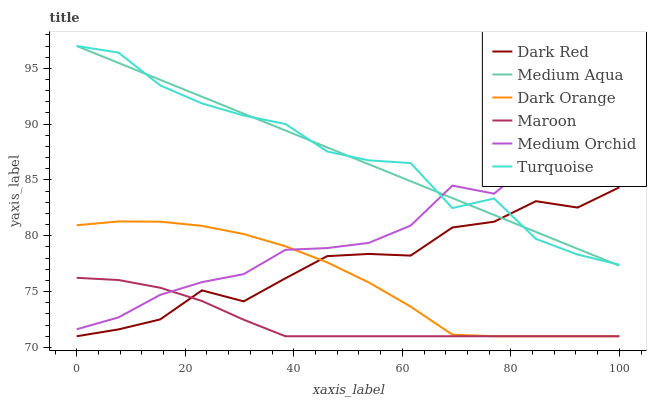Does Dark Red have the minimum area under the curve?
Answer yes or no. No. Does Dark Red have the maximum area under the curve?
Answer yes or no. No. Is Dark Red the smoothest?
Answer yes or no. No. Is Dark Red the roughest?
Answer yes or no. No. Does Turquoise have the lowest value?
Answer yes or no. No. Does Dark Red have the highest value?
Answer yes or no. No. Is Dark Orange less than Turquoise?
Answer yes or no. Yes. Is Turquoise greater than Dark Orange?
Answer yes or no. Yes. Does Dark Orange intersect Turquoise?
Answer yes or no. No. 